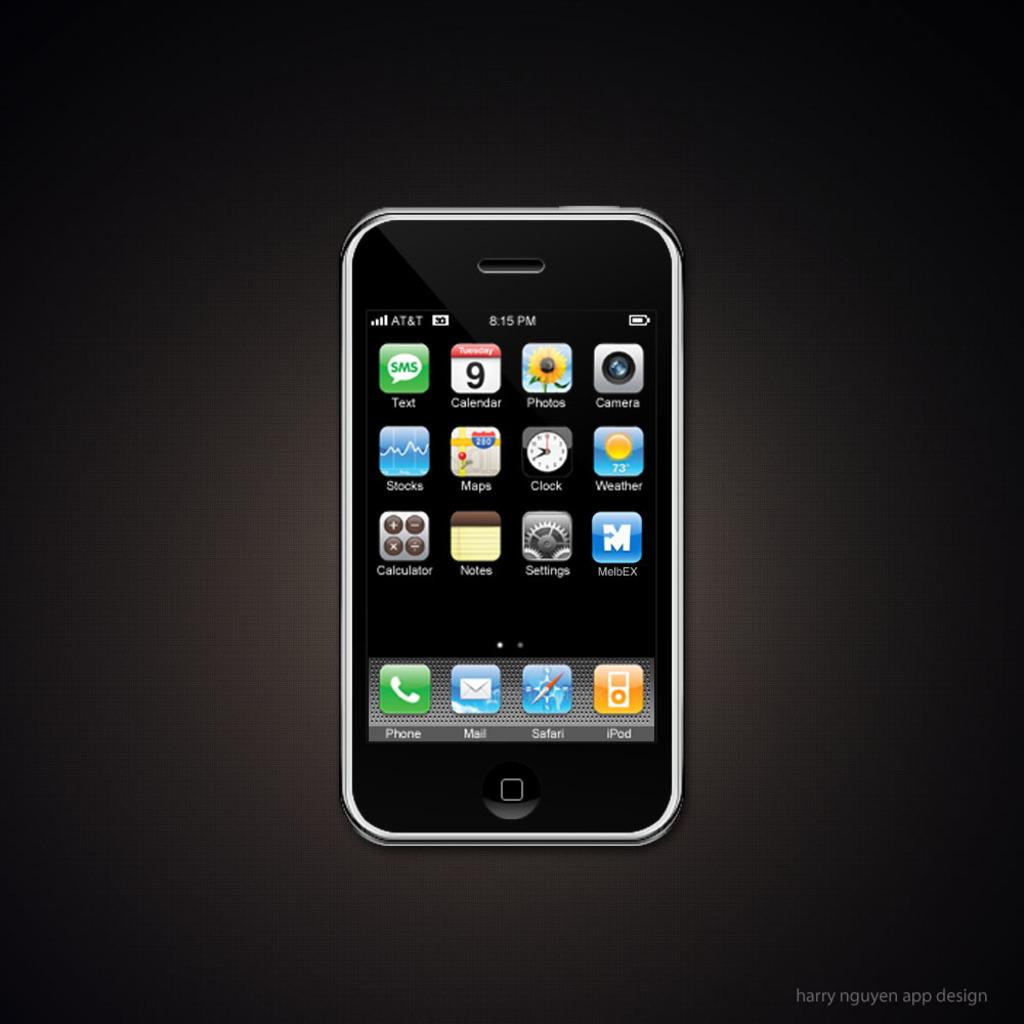What time is displayed?
Your answer should be compact. 8:15 pm. 